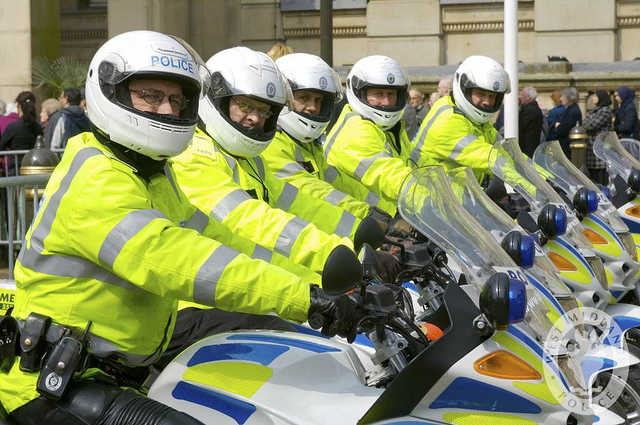Please transcribe the text information in this image. POLICE WEST POLICE 